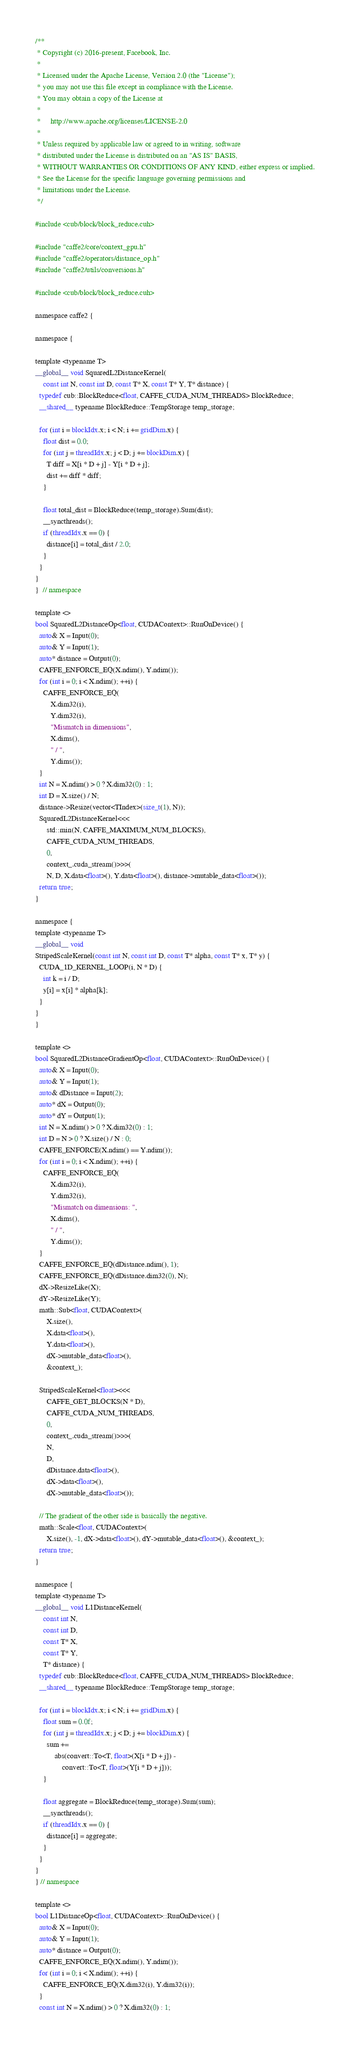Convert code to text. <code><loc_0><loc_0><loc_500><loc_500><_Cuda_>/**
 * Copyright (c) 2016-present, Facebook, Inc.
 *
 * Licensed under the Apache License, Version 2.0 (the "License");
 * you may not use this file except in compliance with the License.
 * You may obtain a copy of the License at
 *
 *     http://www.apache.org/licenses/LICENSE-2.0
 *
 * Unless required by applicable law or agreed to in writing, software
 * distributed under the License is distributed on an "AS IS" BASIS,
 * WITHOUT WARRANTIES OR CONDITIONS OF ANY KIND, either express or implied.
 * See the License for the specific language governing permissions and
 * limitations under the License.
 */

#include <cub/block/block_reduce.cuh>

#include "caffe2/core/context_gpu.h"
#include "caffe2/operators/distance_op.h"
#include "caffe2/utils/conversions.h"

#include <cub/block/block_reduce.cuh>

namespace caffe2 {

namespace {

template <typename T>
__global__ void SquaredL2DistanceKernel(
    const int N, const int D, const T* X, const T* Y, T* distance) {
  typedef cub::BlockReduce<float, CAFFE_CUDA_NUM_THREADS> BlockReduce;
  __shared__ typename BlockReduce::TempStorage temp_storage;

  for (int i = blockIdx.x; i < N; i += gridDim.x) {
    float dist = 0.0;
    for (int j = threadIdx.x; j < D; j += blockDim.x) {
      T diff = X[i * D + j] - Y[i * D + j];
      dist += diff * diff;
    }

    float total_dist = BlockReduce(temp_storage).Sum(dist);
    __syncthreads();
    if (threadIdx.x == 0) {
      distance[i] = total_dist / 2.0;
    }
  }
}
}  // namespace

template <>
bool SquaredL2DistanceOp<float, CUDAContext>::RunOnDevice() {
  auto& X = Input(0);
  auto& Y = Input(1);
  auto* distance = Output(0);
  CAFFE_ENFORCE_EQ(X.ndim(), Y.ndim());
  for (int i = 0; i < X.ndim(); ++i) {
    CAFFE_ENFORCE_EQ(
        X.dim32(i),
        Y.dim32(i),
        "Mismatch in dimensions",
        X.dims(),
        " / ",
        Y.dims());
  }
  int N = X.ndim() > 0 ? X.dim32(0) : 1;
  int D = X.size() / N;
  distance->Resize(vector<TIndex>(size_t(1), N));
  SquaredL2DistanceKernel<<<
      std::min(N, CAFFE_MAXIMUM_NUM_BLOCKS),
      CAFFE_CUDA_NUM_THREADS,
      0,
      context_.cuda_stream()>>>(
      N, D, X.data<float>(), Y.data<float>(), distance->mutable_data<float>());
  return true;
}

namespace {
template <typename T>
__global__ void
StripedScaleKernel(const int N, const int D, const T* alpha, const T* x, T* y) {
  CUDA_1D_KERNEL_LOOP(i, N * D) {
    int k = i / D;
    y[i] = x[i] * alpha[k];
  }
}
}

template <>
bool SquaredL2DistanceGradientOp<float, CUDAContext>::RunOnDevice() {
  auto& X = Input(0);
  auto& Y = Input(1);
  auto& dDistance = Input(2);
  auto* dX = Output(0);
  auto* dY = Output(1);
  int N = X.ndim() > 0 ? X.dim32(0) : 1;
  int D = N > 0 ? X.size() / N : 0;
  CAFFE_ENFORCE(X.ndim() == Y.ndim());
  for (int i = 0; i < X.ndim(); ++i) {
    CAFFE_ENFORCE_EQ(
        X.dim32(i),
        Y.dim32(i),
        "Mismatch on dimensions: ",
        X.dims(),
        " / ",
        Y.dims());
  }
  CAFFE_ENFORCE_EQ(dDistance.ndim(), 1);
  CAFFE_ENFORCE_EQ(dDistance.dim32(0), N);
  dX->ResizeLike(X);
  dY->ResizeLike(Y);
  math::Sub<float, CUDAContext>(
      X.size(),
      X.data<float>(),
      Y.data<float>(),
      dX->mutable_data<float>(),
      &context_);

  StripedScaleKernel<float><<<
      CAFFE_GET_BLOCKS(N * D),
      CAFFE_CUDA_NUM_THREADS,
      0,
      context_.cuda_stream()>>>(
      N,
      D,
      dDistance.data<float>(),
      dX->data<float>(),
      dX->mutable_data<float>());

  // The gradient of the other side is basically the negative.
  math::Scale<float, CUDAContext>(
      X.size(), -1, dX->data<float>(), dY->mutable_data<float>(), &context_);
  return true;
}

namespace {
template <typename T>
__global__ void L1DistanceKernel(
    const int N,
    const int D,
    const T* X,
    const T* Y,
    T* distance) {
  typedef cub::BlockReduce<float, CAFFE_CUDA_NUM_THREADS> BlockReduce;
  __shared__ typename BlockReduce::TempStorage temp_storage;

  for (int i = blockIdx.x; i < N; i += gridDim.x) {
    float sum = 0.0f;
    for (int j = threadIdx.x; j < D; j += blockDim.x) {
      sum +=
          abs(convert::To<T, float>(X[i * D + j]) -
              convert::To<T, float>(Y[i * D + j]));
    }

    float aggregate = BlockReduce(temp_storage).Sum(sum);
    __syncthreads();
    if (threadIdx.x == 0) {
      distance[i] = aggregate;
    }
  }
}
} // namespace

template <>
bool L1DistanceOp<float, CUDAContext>::RunOnDevice() {
  auto& X = Input(0);
  auto& Y = Input(1);
  auto* distance = Output(0);
  CAFFE_ENFORCE_EQ(X.ndim(), Y.ndim());
  for (int i = 0; i < X.ndim(); ++i) {
    CAFFE_ENFORCE_EQ(X.dim32(i), Y.dim32(i));
  }
  const int N = X.ndim() > 0 ? X.dim32(0) : 1;</code> 